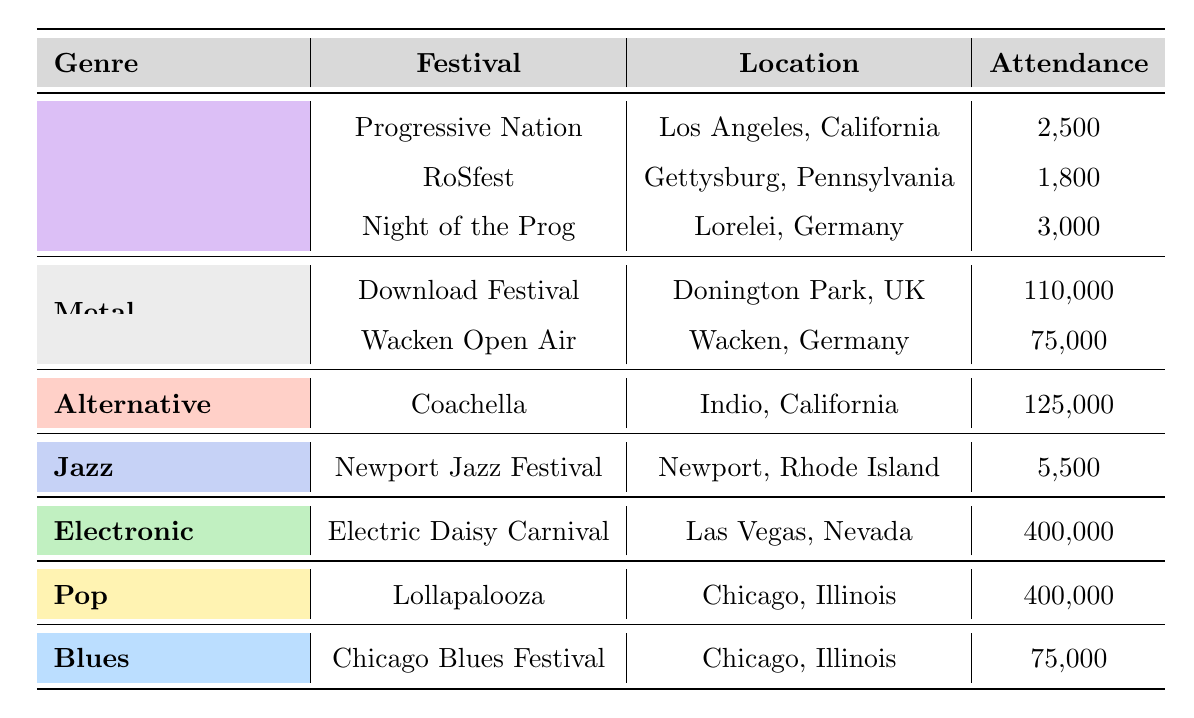What is the attendance at the RoSfest? The table shows that the attendance at RoSfest, which is a festival for Progressive Rock genre located in Gettysburg, Pennsylvania, is 1,800.
Answer: 1,800 Which festival had the highest attendance overall? Looking at the attendance figures in the table, Electric Daisy Carnival and Lollapalooza both have the highest attendance, which is 400,000.
Answer: 400,000 What is the total attendance for Progressive Rock genres listed in the table? The attendance figures for Progressive Rock festivals are 2,500 (Progressive Nation) + 1,800 (RoSfest) + 3,000 (Night of the Prog), which totals to 7,300.
Answer: 7,300 Is there a Jazz festival listed with an attendance of more than 6,000? The table shows the Newport Jazz Festival with an attendance of 5,500, which is less than 6,000, meaning there is no Jazz festival listed with an attendance of more than 6,000.
Answer: No How much higher is the attendance at Download Festival compared to Night of the Prog? The attendance at Download Festival is 110,000, while Night of the Prog stands at 3,000. The difference is 110,000 - 3,000 = 107,000, showing that Download Festival has an attendance that is 107,000 higher.
Answer: 107,000 Are there any festivals in California listed in the table? Yes, both Progressive Nation and Coachella are festivals located in California as indicated in the table.
Answer: Yes What is the median attendance for the festivals listed? To find the median, we need to list the attendance figures: 1,800, 2,500, 3,000, 5,500, 7,500, 75,000, 110,000, and 400,000. There are 8 entries, so the median will be the average of the 4th and 5th values (5,500 and 7,500), resulting in (5,500 + 7,500) / 2 = 6,500.
Answer: 6,500 Which genre had the lowest attendance at its festivals? By comparing attendance figures, we see that the Jazz genre has the lowest attendance at 5,500 for the Newport Jazz Festival.
Answer: Jazz How many more people attended the Electronic festival compared to the Progressive Rock festival with the highest attendance? The Electronic festival (Electric Daisy Carnival) had an attendance of 400,000, while Night of the Prog, the highest for Progressive Rock, had 3,000. The difference is 400,000 - 3,000 = 397,000.
Answer: 397,000 